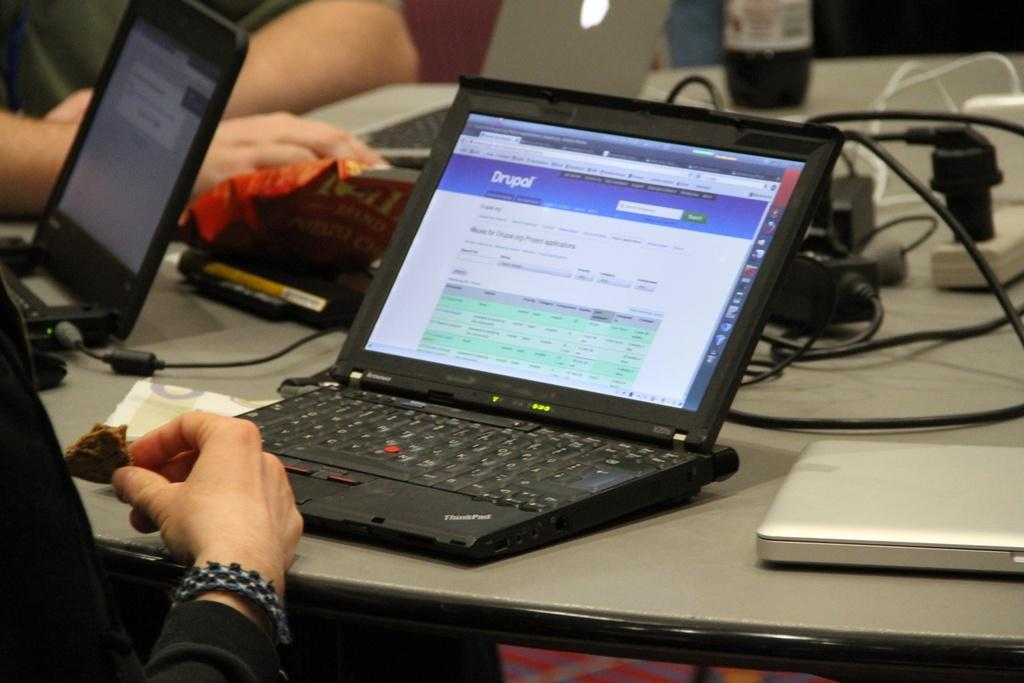<image>
Write a terse but informative summary of the picture. a thinkpad laptop opened to a screen from drupal 